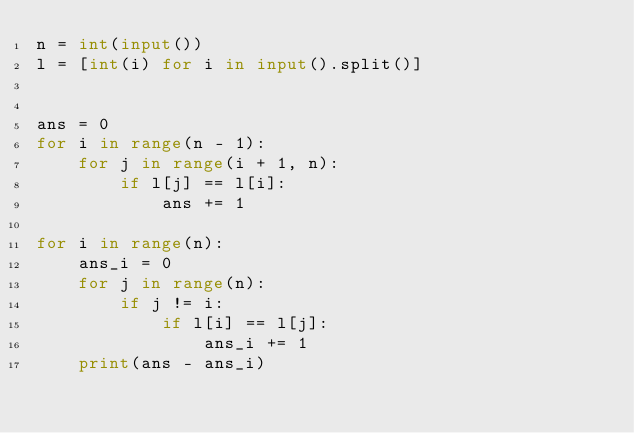Convert code to text. <code><loc_0><loc_0><loc_500><loc_500><_Python_>n = int(input())
l = [int(i) for i in input().split()]


ans = 0
for i in range(n - 1):
    for j in range(i + 1, n):
        if l[j] == l[i]:
            ans += 1

for i in range(n):
    ans_i = 0
    for j in range(n):
        if j != i:
            if l[i] == l[j]:
                ans_i += 1
    print(ans - ans_i)</code> 